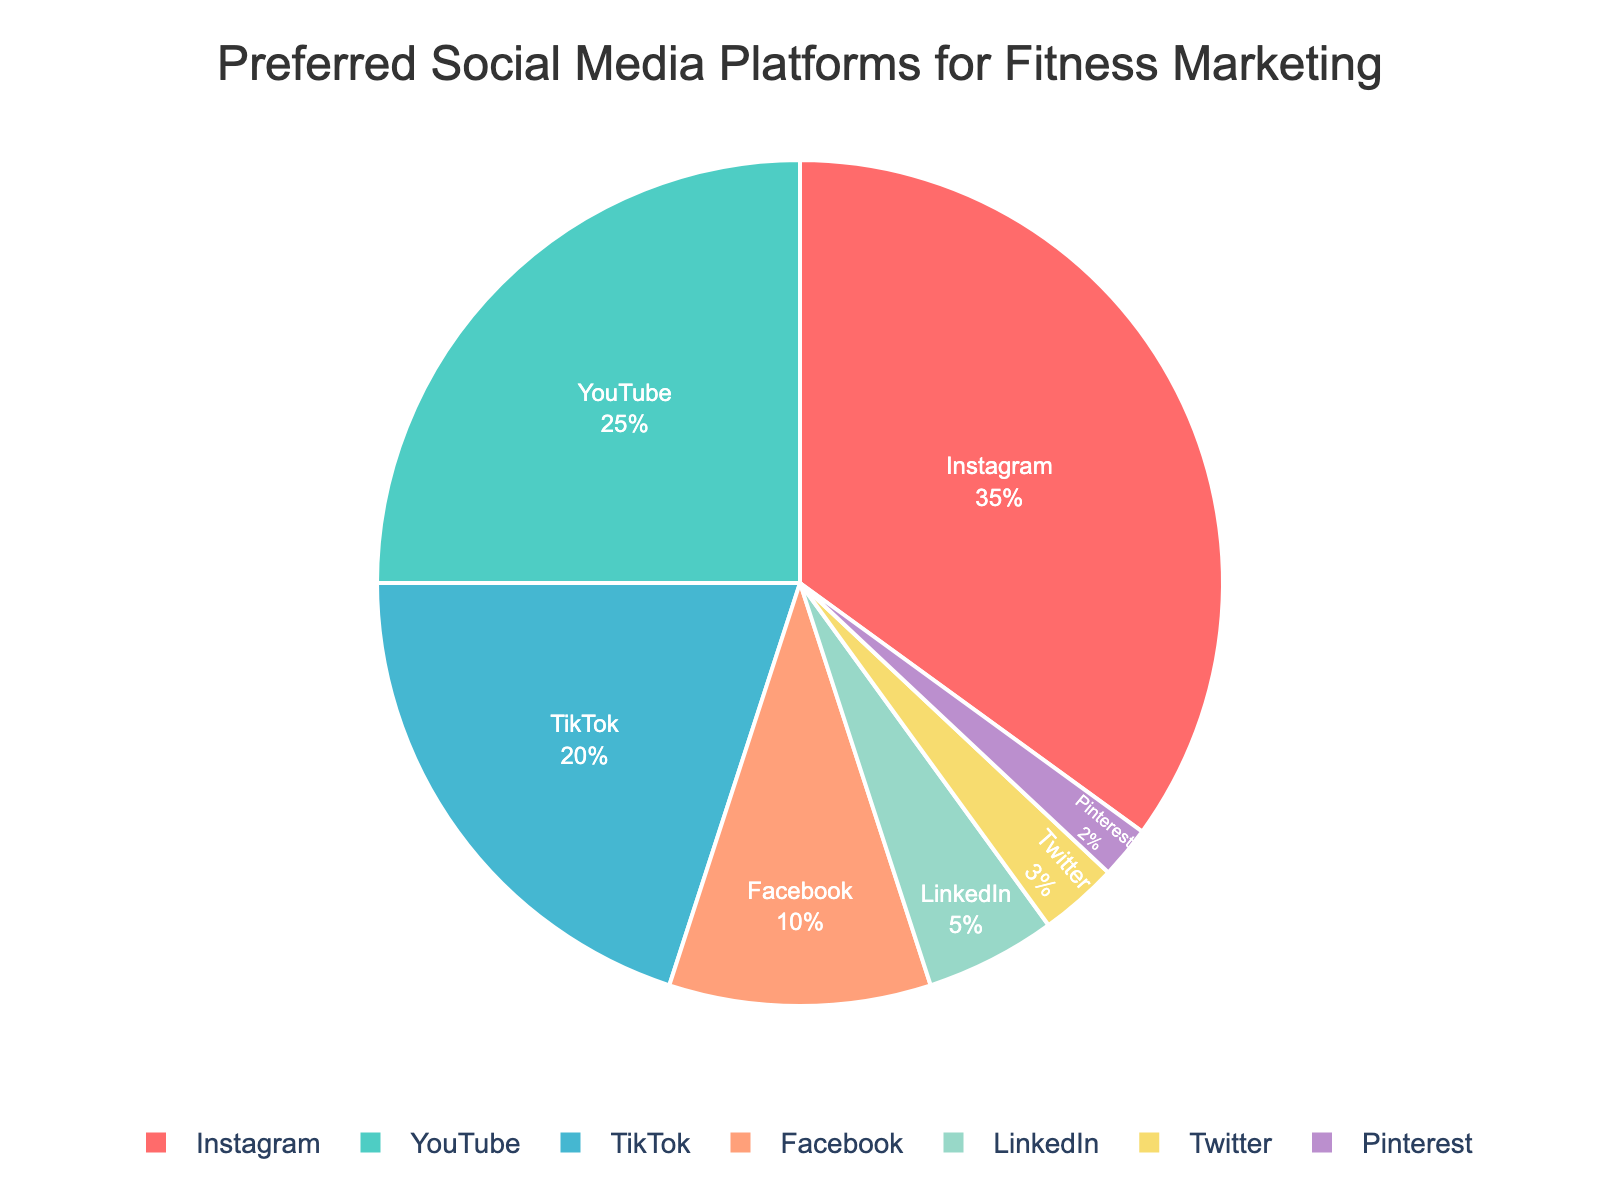What's the most preferred social media platform for fitness marketing? The pie chart shows the distribution of preferred social media platforms for fitness marketing. The largest segment is Instagram, indicating it is the most preferred platform with 35%.
Answer: Instagram Which platform has the least preference? By observing the smallest segment in the pie chart, Pinterest has the smallest percentage, indicating it is the least preferred platform for fitness marketing with only 2%.
Answer: Pinterest What is the combined percentage of Instagram and YouTube? The pie chart shows that Instagram has 35% and YouTube has 25%. Adding these two percentages together gives 35% + 25% = 60%.
Answer: 60% Which platforms have a preference greater than 20%? In the pie chart, the platforms with percentages greater than 20% are Instagram at 35%, YouTube at 25%, and TikTok at 20%. Since TikTok is exactly 20%, it does not exceed 20%. Therefore, only Instagram and YouTube meet this criterion.
Answer: Instagram, YouTube How much more preferred is Instagram compared to Facebook? From the pie chart, Instagram's preference is 35% and Facebook's preference is 10%. Subtracting Facebook's percentage from Instagram's gives 35% - 10% = 25%. This shows that Instagram is 25% more preferred than Facebook for fitness marketing.
Answer: 25% What percentage of preferences do platforms other than Instagram hold collectively? The total percentage for all platforms is 100%. Subtracting Instagram's preference of 35% from 100% gives us the combined preference for all other platforms: 100% - 35% = 65%.
Answer: 65% How does Twitter's preference compare to LinkedIn's? The pie chart indicates that Twitter has a preference of 3%, and LinkedIn has a preference of 5%. Thus, LinkedIn is more preferred than Twitter for fitness marketing.
Answer: LinkedIn What are the colors used for the platforms with more than 10% preference? The colors used in the pie chart can be visually identified: Instagram (red), YouTube (green), and TikTok (blue) are the platforms with more than 10% preference.
Answer: red for Instagram, green for YouTube, blue for TikTok 